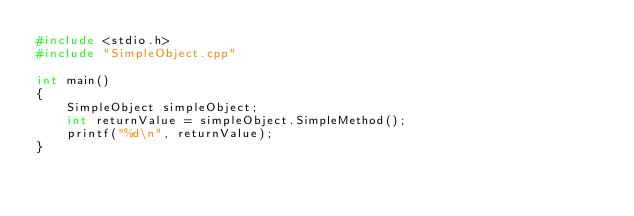<code> <loc_0><loc_0><loc_500><loc_500><_C++_>#include <stdio.h>
#include "SimpleObject.cpp"

int main()
{
    SimpleObject simpleObject;
    int returnValue = simpleObject.SimpleMethod();
    printf("%d\n", returnValue);
}</code> 